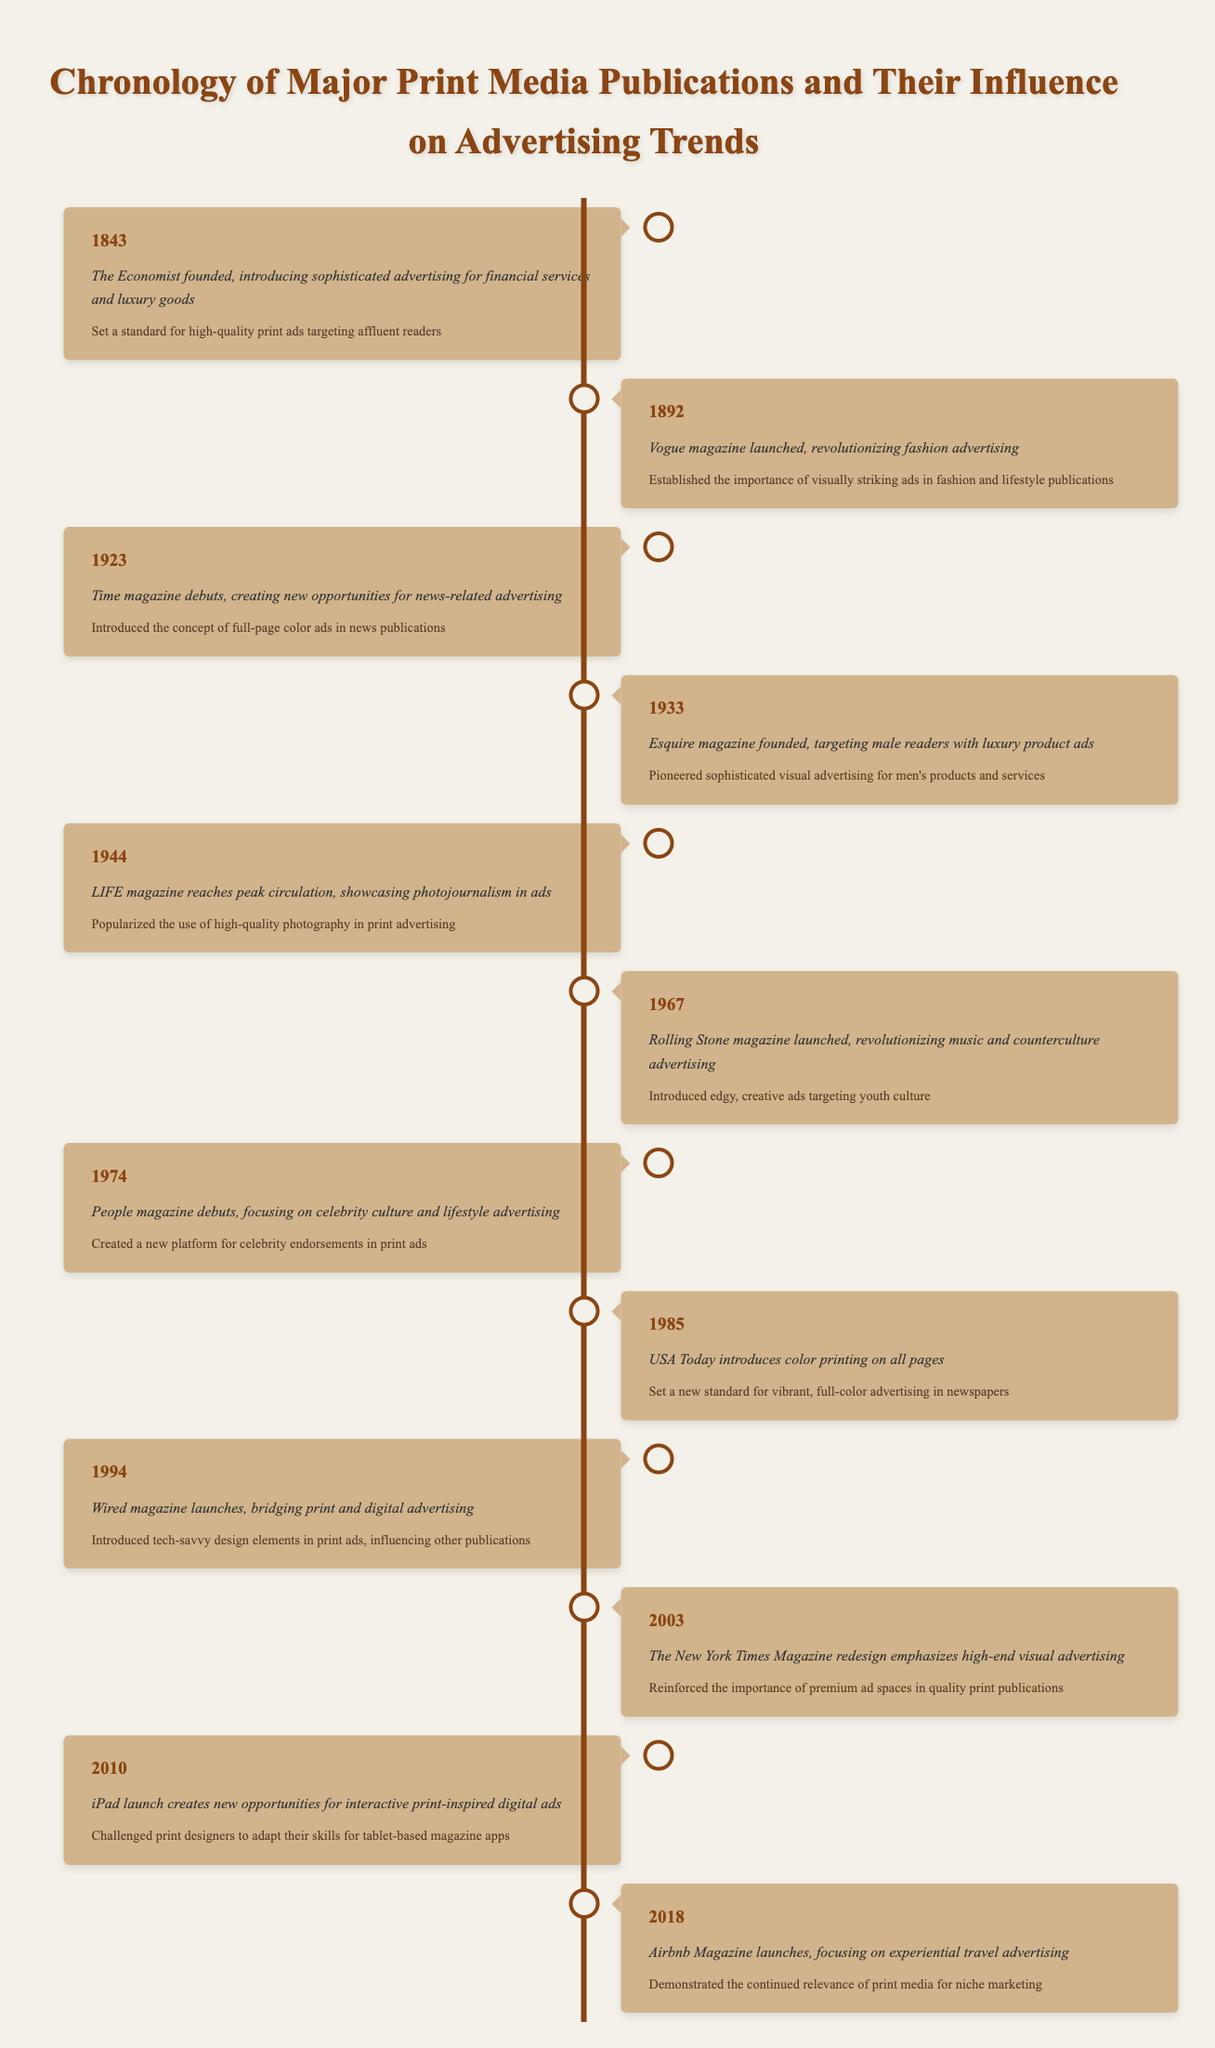What year was Vogue magazine launched? The table shows an event that occurred in 1892 where Vogue magazine was launched.
Answer: 1892 What impact did The Economist have on print advertising? According to the table, The Economist established a standard for high-quality print ads targeting affluent readers.
Answer: Set a standard for high-quality print ads Which magazine introduced full-page color ads in news publications? The table indicates that Time magazine, which debuted in 1923, introduced the concept of full-page color ads.
Answer: Time magazine Was LIFE magazine's peak circulation influential in popularizing high-quality photography in ads? Yes, the table specifies that LIFE magazine reached peak circulation and popularized high-quality photography in print advertising.
Answer: Yes What was the major advertising focus of People magazine when it debuted? The table details that People magazine focused on celebrity culture and lifestyle advertising when it debuted in 1974.
Answer: Celebrity culture and lifestyle advertising In which decade did Rolling Stone magazine launch, and what was its significance? Rolling Stone launched in 1967, revolutionizing music and counterculture advertising by introducing edgy, creative ads targeting youth culture. The decade is the 1960s.
Answer: 1960s Which publication is noted for bridging print and digital advertising in 1994? The timeline specifies that Wired magazine, launched in 1994, is credited with bridging print and digital advertising.
Answer: Wired magazine What is the chronological order of the first three magazines listed? By referring to the years provided in the timeline (1843, 1892, 1923), we can establish that The Economist came first, followed by Vogue, then Time magazine.
Answer: The Economist, Vogue, Time Which event demonstrates the continued relevance of print media for niche marketing? The launch of Airbnb Magazine in 2018 demonstrates this, as it focuses on experiential travel advertising according to the table.
Answer: Airbnb Magazine launch How many years passed between the launch of Vogue and the introduction of the full-page color ads by Time magazine? The years are 1892 (Vogue) and 1923 (Time), so subtracting these gives 1923 - 1892 = 31 years.
Answer: 31 years 